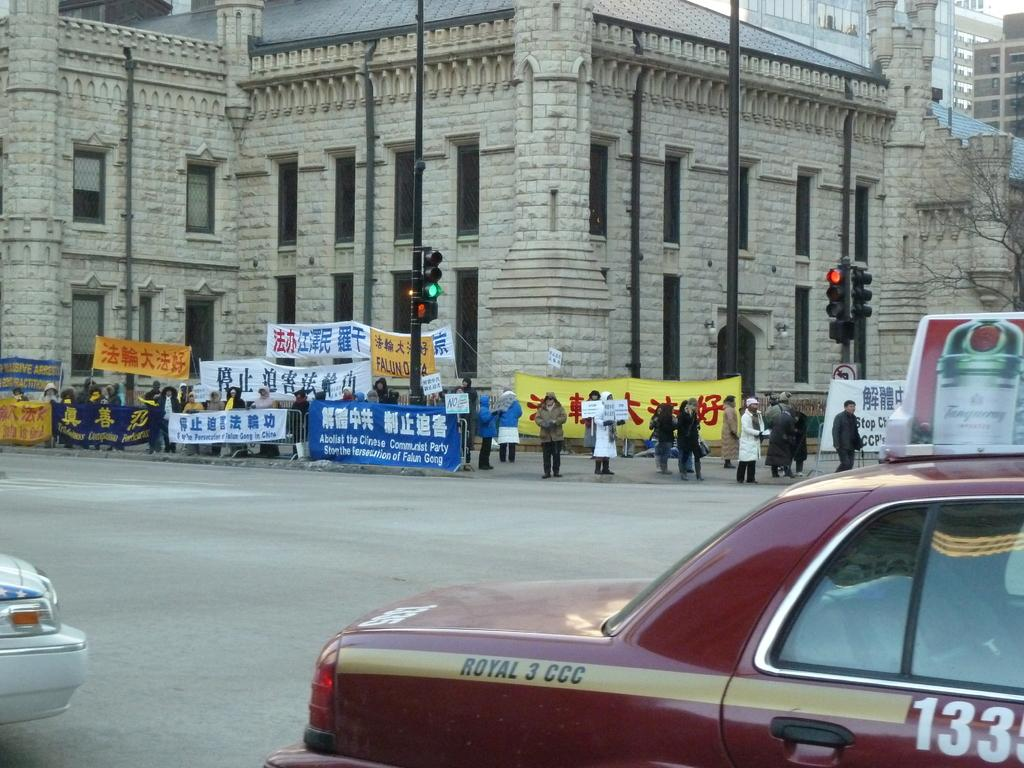<image>
Describe the image concisely. A city street with a group of people holding different banners written in a foreign language and one says in english ABOLISH THE CINEMA COMMUNIST PARTY. 